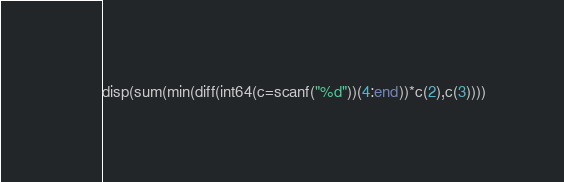Convert code to text. <code><loc_0><loc_0><loc_500><loc_500><_Octave_>disp(sum(min(diff(int64(c=scanf("%d"))(4:end))*c(2),c(3))))</code> 